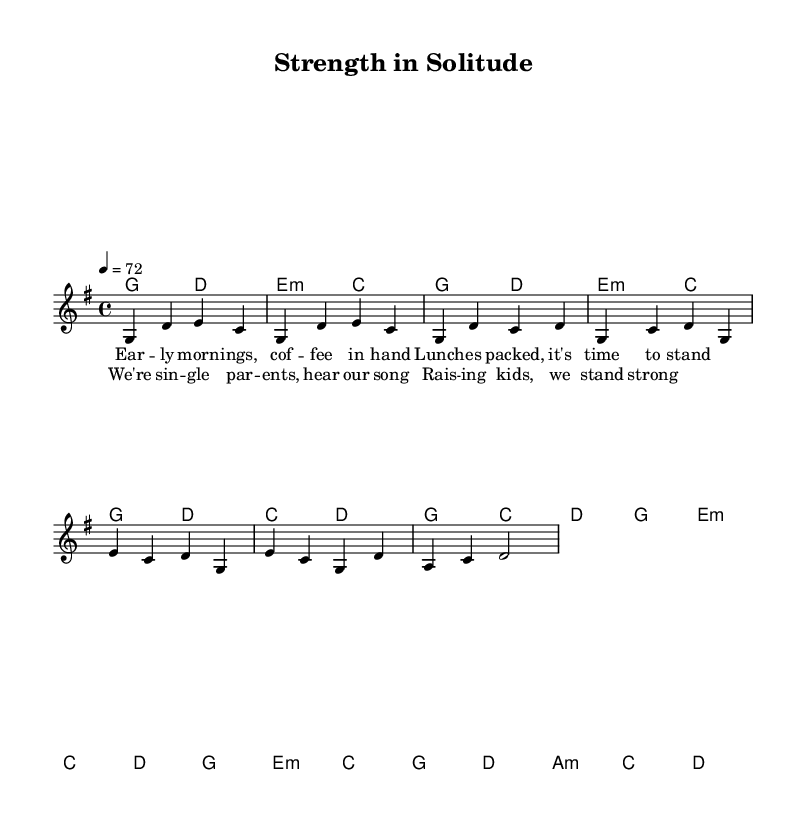What is the key signature of this music? The key signature is G major, which has one sharp (F#).
Answer: G major What is the time signature of the piece? The time signature is four-four, indicating four beats per measure.
Answer: Four-four What is the tempo marking of the music? The tempo marking is quarter note equals seventy-two, indicating the speed of the piece.
Answer: Seventy-two How many measures are included in the chorus? The chorus consists of four measures, as indicated by the number of phrases and the rhythmic structure.
Answer: Four measures What is the first note of the melody? The first note of the melody is G, starting the piece in the upper register.
Answer: G In the bridge, what is the last chord used? The last chord in the bridge is D, concluding that section of the music.
Answer: D What lyrical theme does the song convey? The song conveys a theme of strength and resilience among single parents, as depicted in the lyrics.
Answer: Strength and resilience 